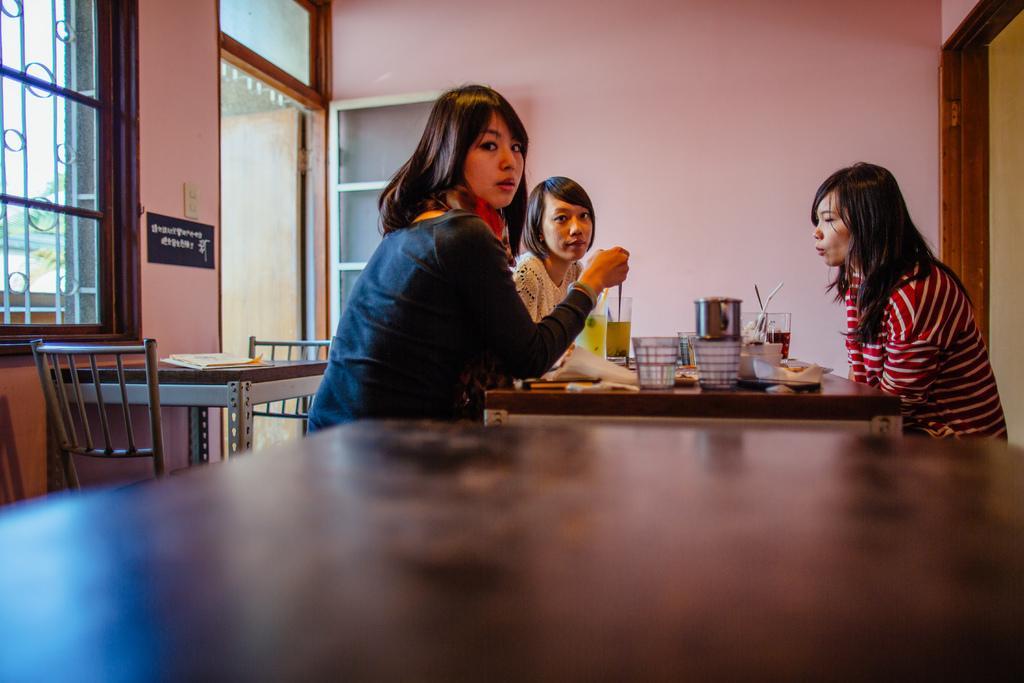Please provide a concise description of this image. In the image we can see there are women who are sitting on chair and on the table there are glasses. 